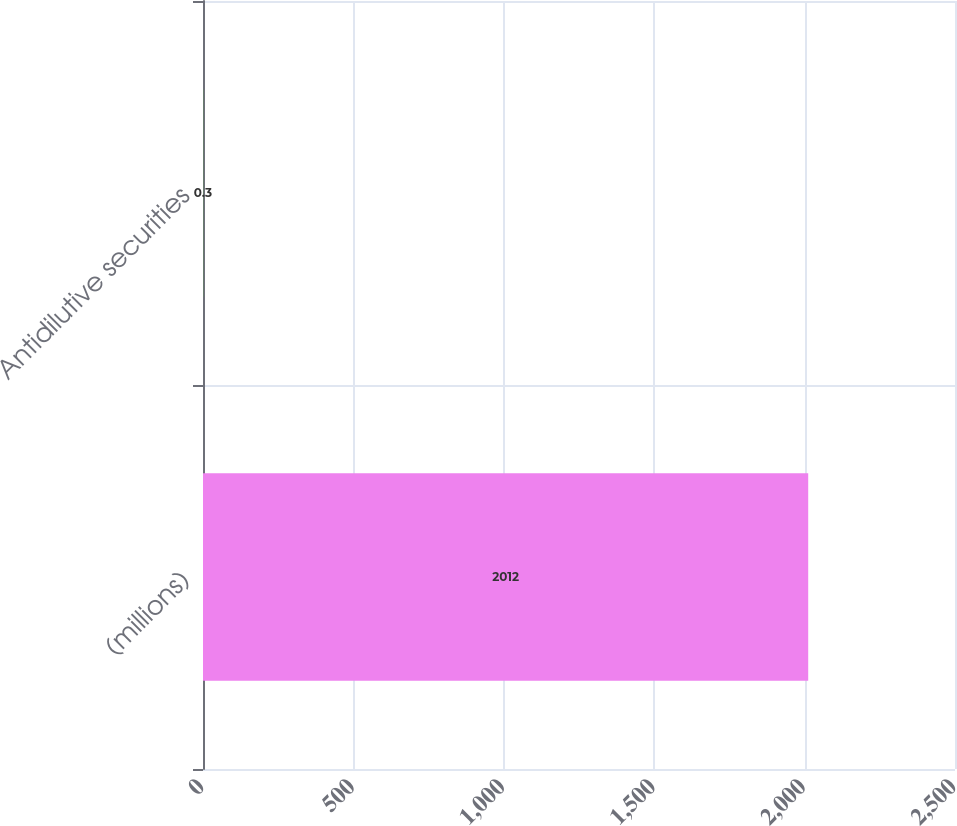Convert chart to OTSL. <chart><loc_0><loc_0><loc_500><loc_500><bar_chart><fcel>(millions)<fcel>Antidilutive securities<nl><fcel>2012<fcel>0.3<nl></chart> 